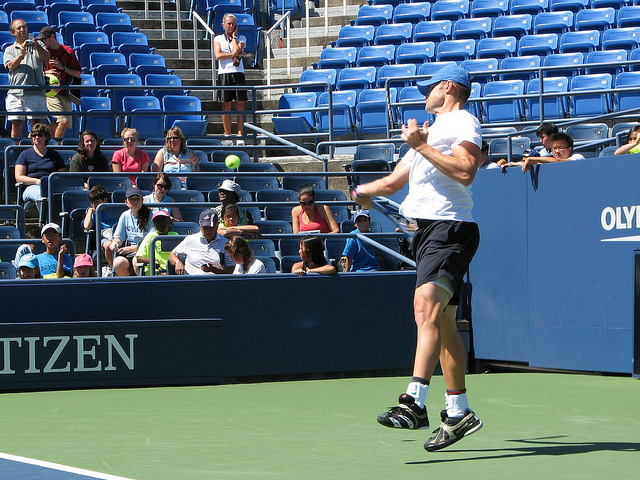Please transcribe the text in this image. TIZEN OLY 